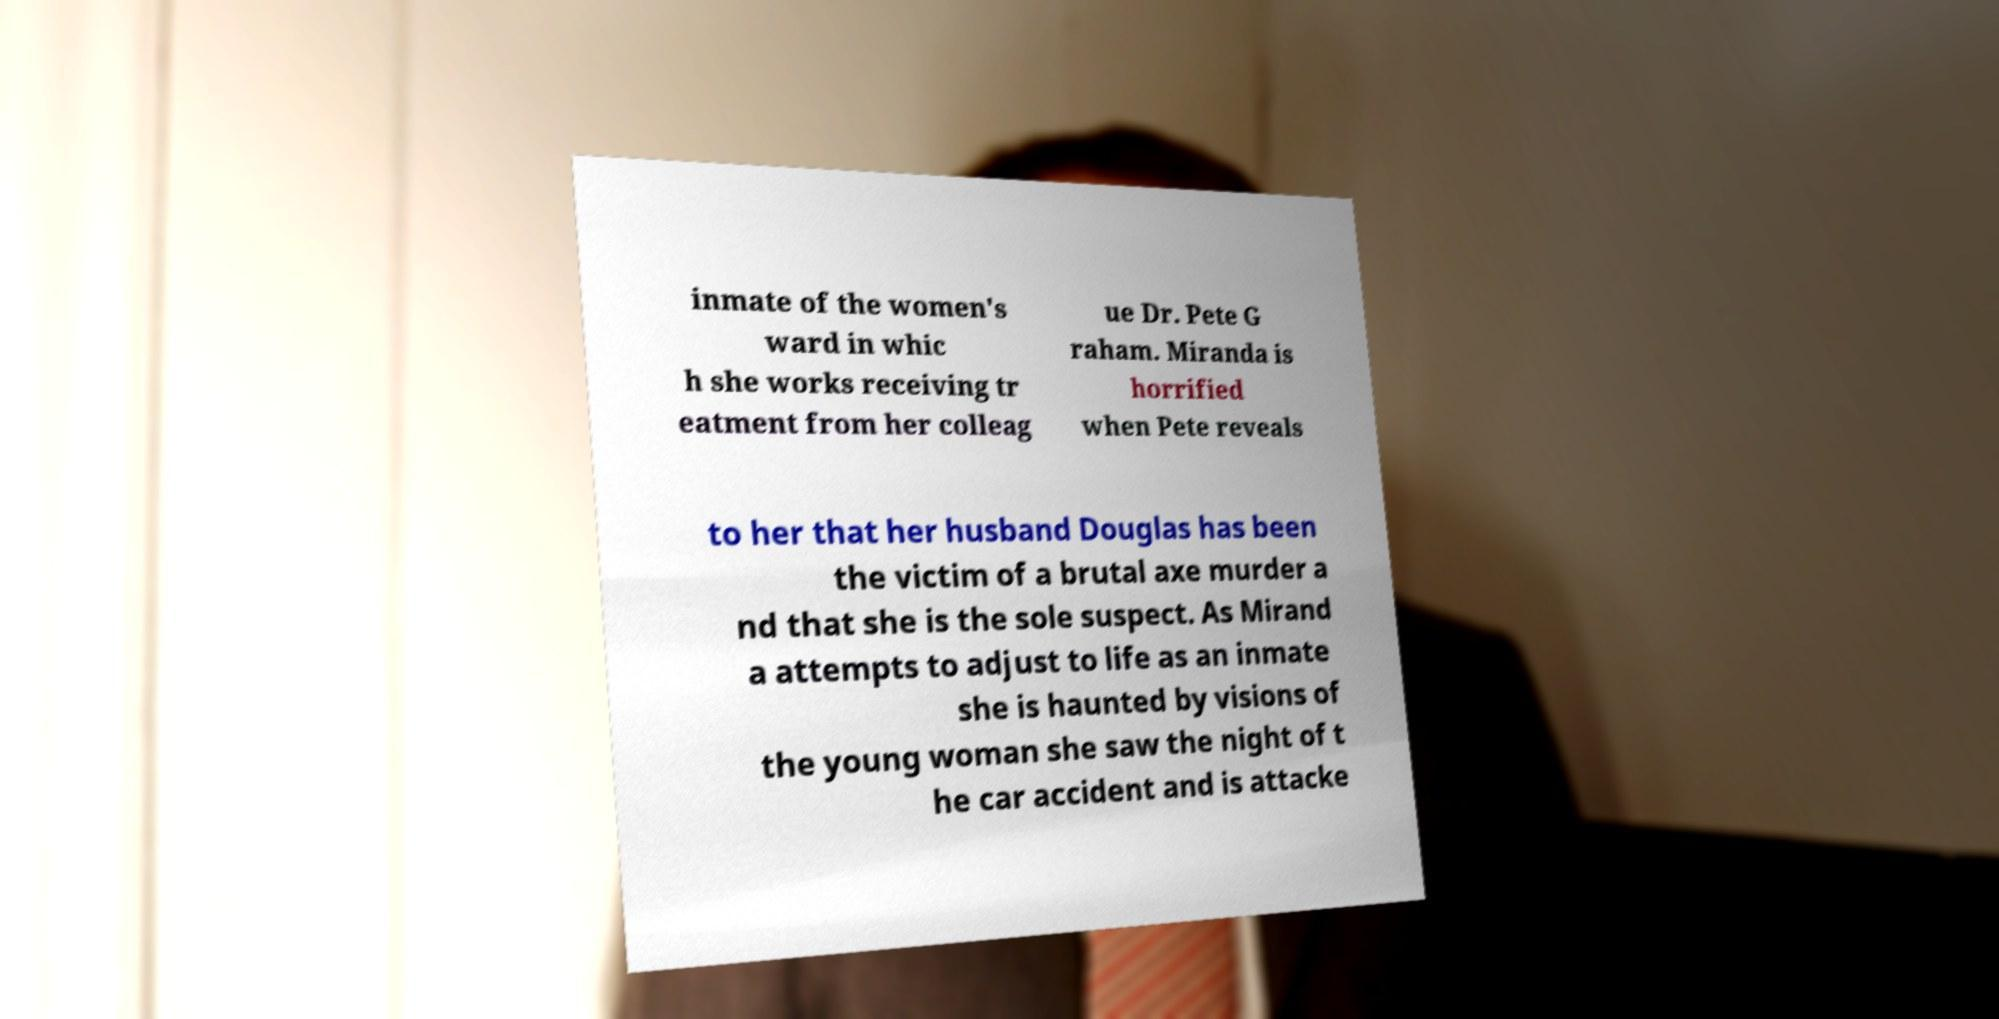Can you accurately transcribe the text from the provided image for me? inmate of the women's ward in whic h she works receiving tr eatment from her colleag ue Dr. Pete G raham. Miranda is horrified when Pete reveals to her that her husband Douglas has been the victim of a brutal axe murder a nd that she is the sole suspect. As Mirand a attempts to adjust to life as an inmate she is haunted by visions of the young woman she saw the night of t he car accident and is attacke 